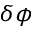<formula> <loc_0><loc_0><loc_500><loc_500>\delta \phi</formula> 